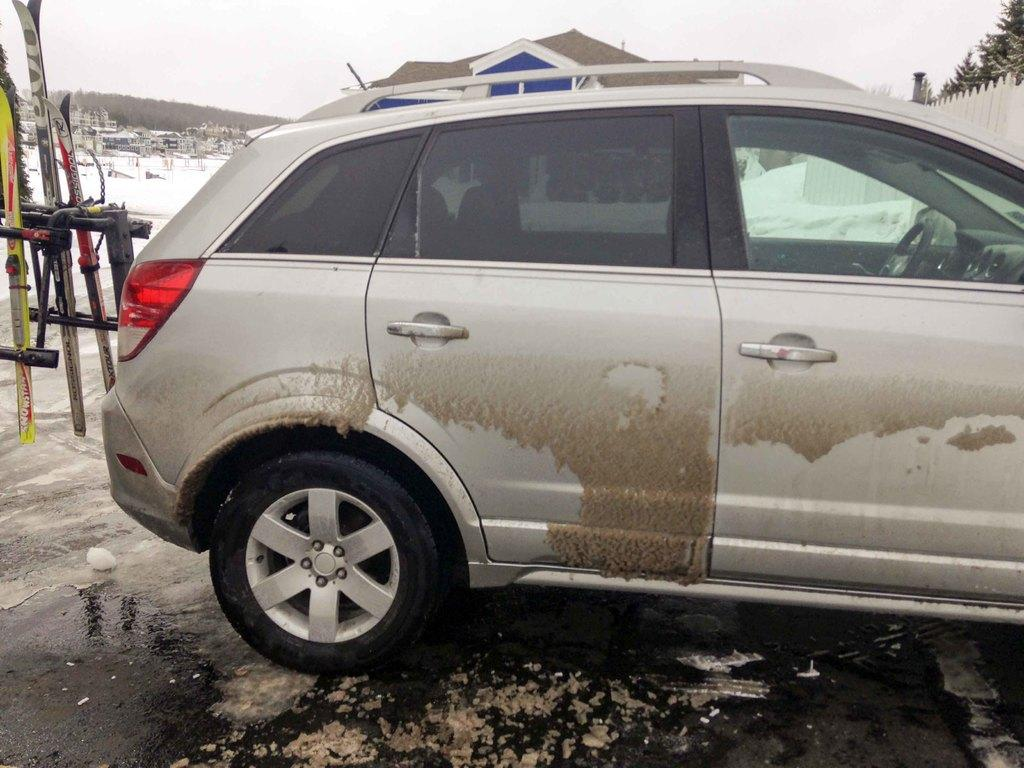What is the main subject in the center of the image? There is a car in the center of the image. What can be seen on the right side of the image? There is a fence and trees on the right side of the image. What is present on the left side of the image? There are boards on the left side of the image. What is visible in the background of the image? There is a hill, snow, and the sky visible in the background of the image. What type of comb is being used to groom the dog in the image? There is no dog or comb present in the image. 